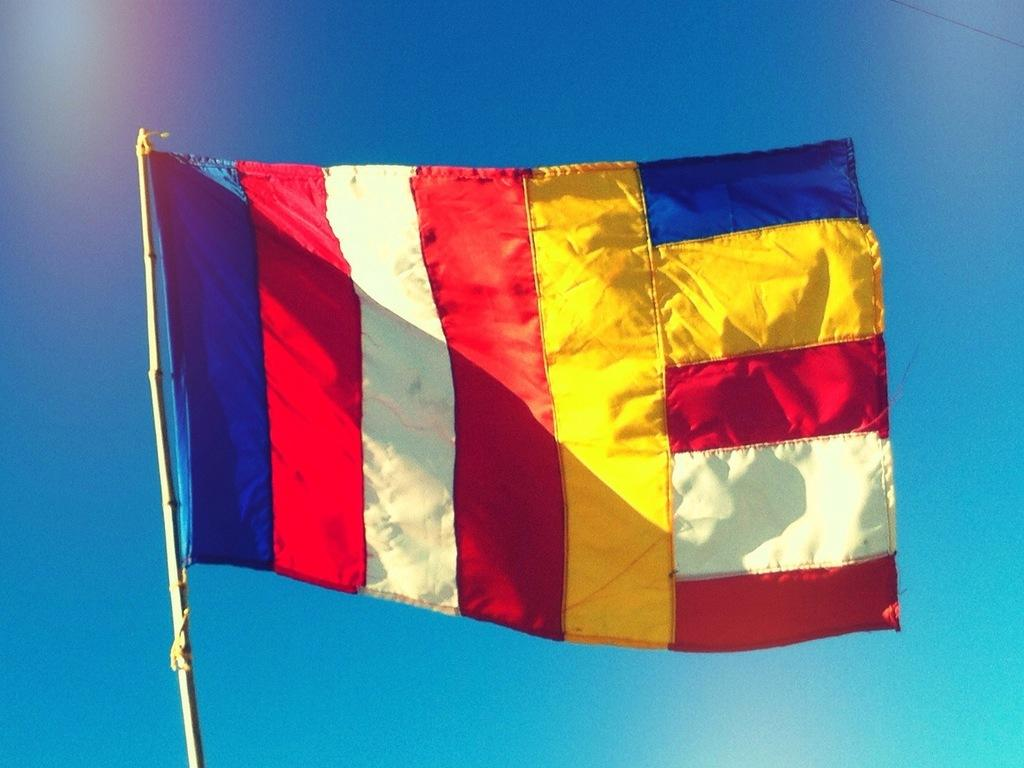What is the main object in the image? There is a flag in the image. What is the flag attached to? The flag is attached to a pole in the image. What can be seen in the background of the image? The sky is visible in the image. What letter is written on the flag in the image? There is no letter written on the flag in the image. Is there a camp visible in the image? There is no camp present in the image. 